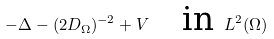<formula> <loc_0><loc_0><loc_500><loc_500>- \Delta - ( 2 D _ { \Omega } ) ^ { - 2 } + V \quad \text {in} \ L ^ { 2 } ( \Omega )</formula> 